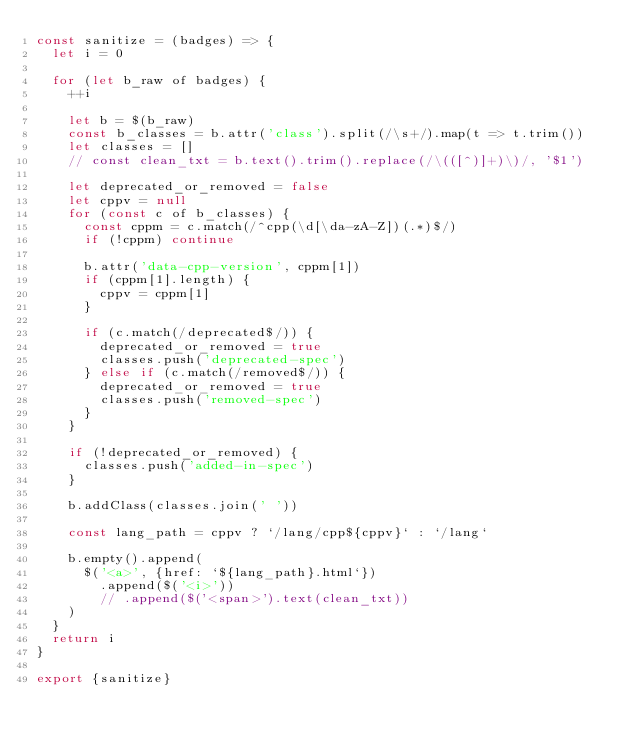<code> <loc_0><loc_0><loc_500><loc_500><_JavaScript_>const sanitize = (badges) => {
  let i = 0

  for (let b_raw of badges) {
    ++i

    let b = $(b_raw)
    const b_classes = b.attr('class').split(/\s+/).map(t => t.trim())
    let classes = []
    // const clean_txt = b.text().trim().replace(/\(([^)]+)\)/, '$1')

    let deprecated_or_removed = false
    let cppv = null
    for (const c of b_classes) {
      const cppm = c.match(/^cpp(\d[\da-zA-Z])(.*)$/)
      if (!cppm) continue

      b.attr('data-cpp-version', cppm[1])
      if (cppm[1].length) {
        cppv = cppm[1]
      }

      if (c.match(/deprecated$/)) {
        deprecated_or_removed = true
        classes.push('deprecated-spec')
      } else if (c.match(/removed$/)) {
        deprecated_or_removed = true
        classes.push('removed-spec')
      }
    }

    if (!deprecated_or_removed) {
      classes.push('added-in-spec')
    }

    b.addClass(classes.join(' '))

    const lang_path = cppv ? `/lang/cpp${cppv}` : `/lang`

    b.empty().append(
      $('<a>', {href: `${lang_path}.html`})
        .append($('<i>'))
        // .append($('<span>').text(clean_txt))
    )
  }
  return i
}

export {sanitize}

</code> 